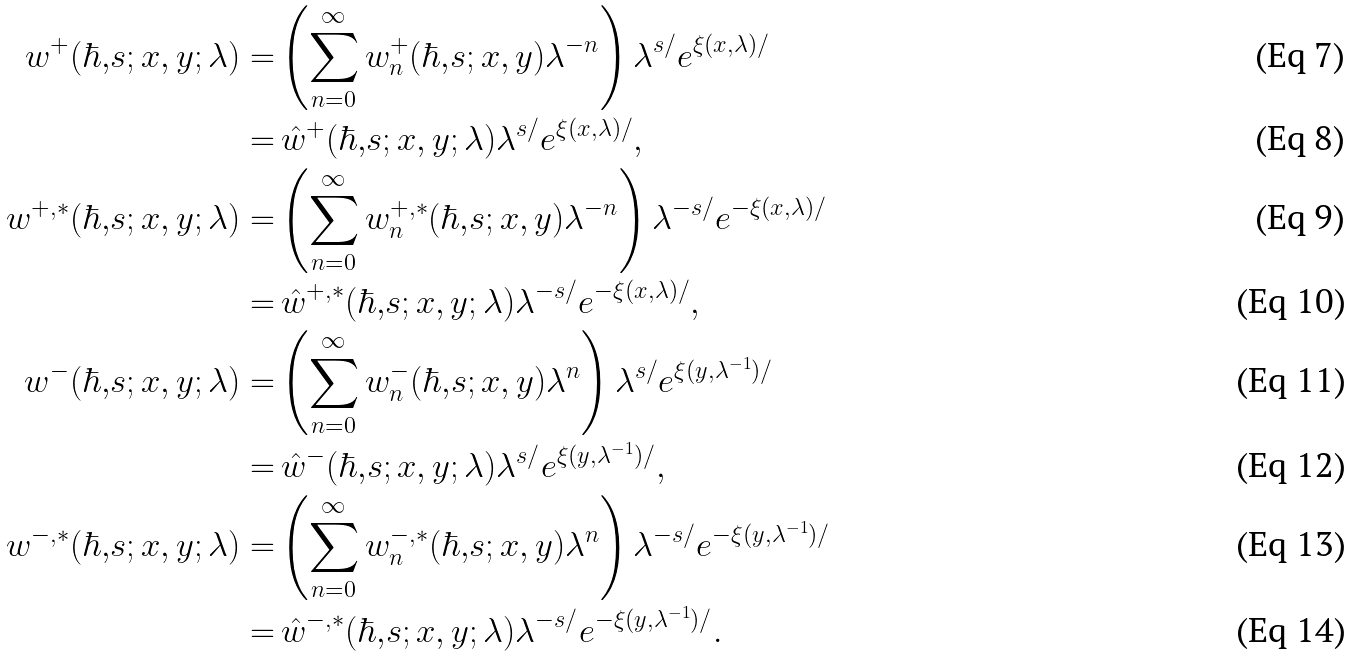<formula> <loc_0><loc_0><loc_500><loc_500>w ^ { + } ( \hbar { , } s ; x , y ; \lambda ) = & \left ( \sum _ { n = 0 } ^ { \infty } w _ { n } ^ { + } ( \hbar { , } s ; x , y ) \lambda ^ { - n } \right ) \lambda ^ { s / } e ^ { \xi ( x , \lambda ) / } \\ = & \, \hat { w } ^ { + } ( \hbar { , } s ; x , y ; \lambda ) \lambda ^ { s / } e ^ { \xi ( x , \lambda ) / } , \\ w ^ { + , * } ( \hbar { , } s ; x , y ; \lambda ) = & \left ( \sum _ { n = 0 } ^ { \infty } w _ { n } ^ { + , * } ( \hbar { , } s ; x , y ) \lambda ^ { - n } \right ) \lambda ^ { - s / } e ^ { - \xi ( x , \lambda ) / } \\ = & \, \hat { w } ^ { + , * } ( \hbar { , } s ; x , y ; \lambda ) \lambda ^ { - s / } e ^ { - \xi ( x , \lambda ) / } , \\ w ^ { - } ( \hbar { , } s ; x , y ; \lambda ) = & \left ( \sum _ { n = 0 } ^ { \infty } w _ { n } ^ { - } ( \hbar { , } s ; x , y ) \lambda ^ { n } \right ) \lambda ^ { s / } e ^ { \xi ( y , \lambda ^ { - 1 } ) / } \\ = & \, \hat { w } ^ { - } ( \hbar { , } s ; x , y ; \lambda ) \lambda ^ { s / } e ^ { \xi ( y , \lambda ^ { - 1 } ) / } , \\ w ^ { - , * } ( \hbar { , } s ; x , y ; \lambda ) = & \left ( \sum _ { n = 0 } ^ { \infty } w _ { n } ^ { - , * } ( \hbar { , } s ; x , y ) \lambda ^ { n } \right ) \lambda ^ { - s / } e ^ { - \xi ( y , \lambda ^ { - 1 } ) / } \\ = & \, \hat { w } ^ { - , * } ( \hbar { , } s ; x , y ; \lambda ) \lambda ^ { - s / } e ^ { - \xi ( y , \lambda ^ { - 1 } ) / } .</formula> 